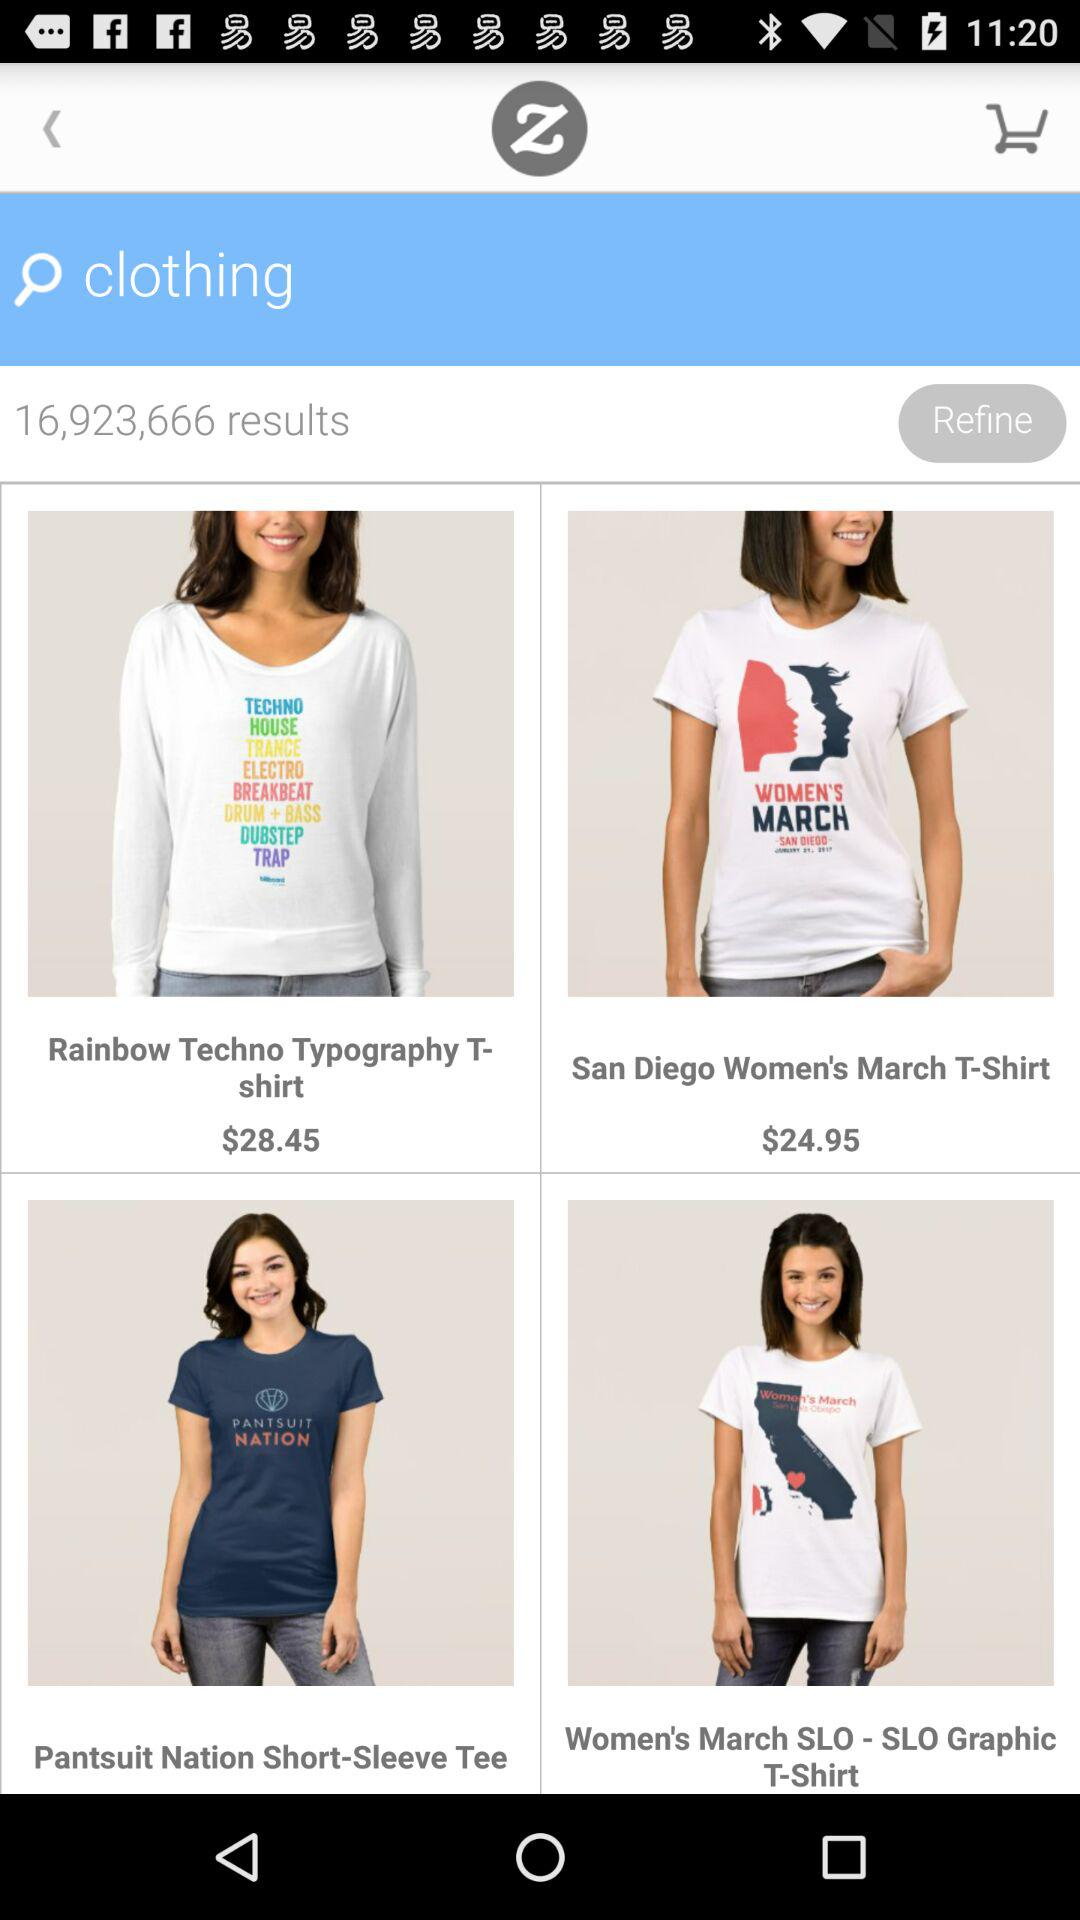What is the currency of the price? The currency is $. 